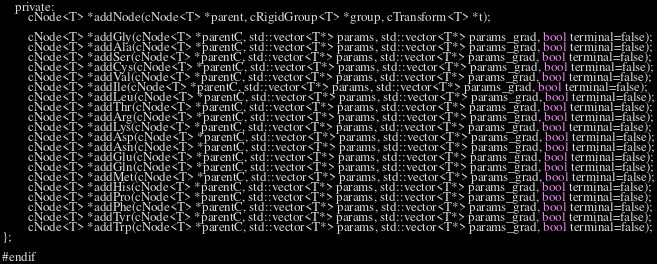<code> <loc_0><loc_0><loc_500><loc_500><_C_>
    private:
        cNode<T> *addNode(cNode<T> *parent, cRigidGroup<T> *group, cTransform<T> *t);
        
        cNode<T> *addGly(cNode<T> *parentC, std::vector<T*> params, std::vector<T*> params_grad, bool terminal=false);
        cNode<T> *addAla(cNode<T> *parentC, std::vector<T*> params, std::vector<T*> params_grad, bool terminal=false);
        cNode<T> *addSer(cNode<T> *parentC, std::vector<T*> params, std::vector<T*> params_grad, bool terminal=false);
        cNode<T> *addCys(cNode<T> *parentC, std::vector<T*> params, std::vector<T*> params_grad, bool terminal=false);
        cNode<T> *addVal(cNode<T> *parentC, std::vector<T*> params, std::vector<T*> params_grad, bool terminal=false);
        cNode<T> *addIle(cNode<T> *parentC, std::vector<T*> params, std::vector<T*> params_grad, bool terminal=false);
        cNode<T> *addLeu(cNode<T> *parentC, std::vector<T*> params, std::vector<T*> params_grad, bool terminal=false);
        cNode<T> *addThr(cNode<T> *parentC, std::vector<T*> params, std::vector<T*> params_grad, bool terminal=false);
        cNode<T> *addArg(cNode<T> *parentC, std::vector<T*> params, std::vector<T*> params_grad, bool terminal=false);
        cNode<T> *addLys(cNode<T> *parentC, std::vector<T*> params, std::vector<T*> params_grad, bool terminal=false);
        cNode<T> *addAsp(cNode<T> *parentC, std::vector<T*> params, std::vector<T*> params_grad, bool terminal=false);
        cNode<T> *addAsn(cNode<T> *parentC, std::vector<T*> params, std::vector<T*> params_grad, bool terminal=false);
        cNode<T> *addGlu(cNode<T> *parentC, std::vector<T*> params, std::vector<T*> params_grad, bool terminal=false);
        cNode<T> *addGln(cNode<T> *parentC, std::vector<T*> params, std::vector<T*> params_grad, bool terminal=false);
        cNode<T> *addMet(cNode<T> *parentC, std::vector<T*> params, std::vector<T*> params_grad, bool terminal=false);
        cNode<T> *addHis(cNode<T> *parentC, std::vector<T*> params, std::vector<T*> params_grad, bool terminal=false);
        cNode<T> *addPro(cNode<T> *parentC, std::vector<T*> params, std::vector<T*> params_grad, bool terminal=false);
        cNode<T> *addPhe(cNode<T> *parentC, std::vector<T*> params, std::vector<T*> params_grad, bool terminal=false);
        cNode<T> *addTyr(cNode<T> *parentC, std::vector<T*> params, std::vector<T*> params_grad, bool terminal=false);
        cNode<T> *addTrp(cNode<T> *parentC, std::vector<T*> params, std::vector<T*> params_grad, bool terminal=false);
};

#endif</code> 